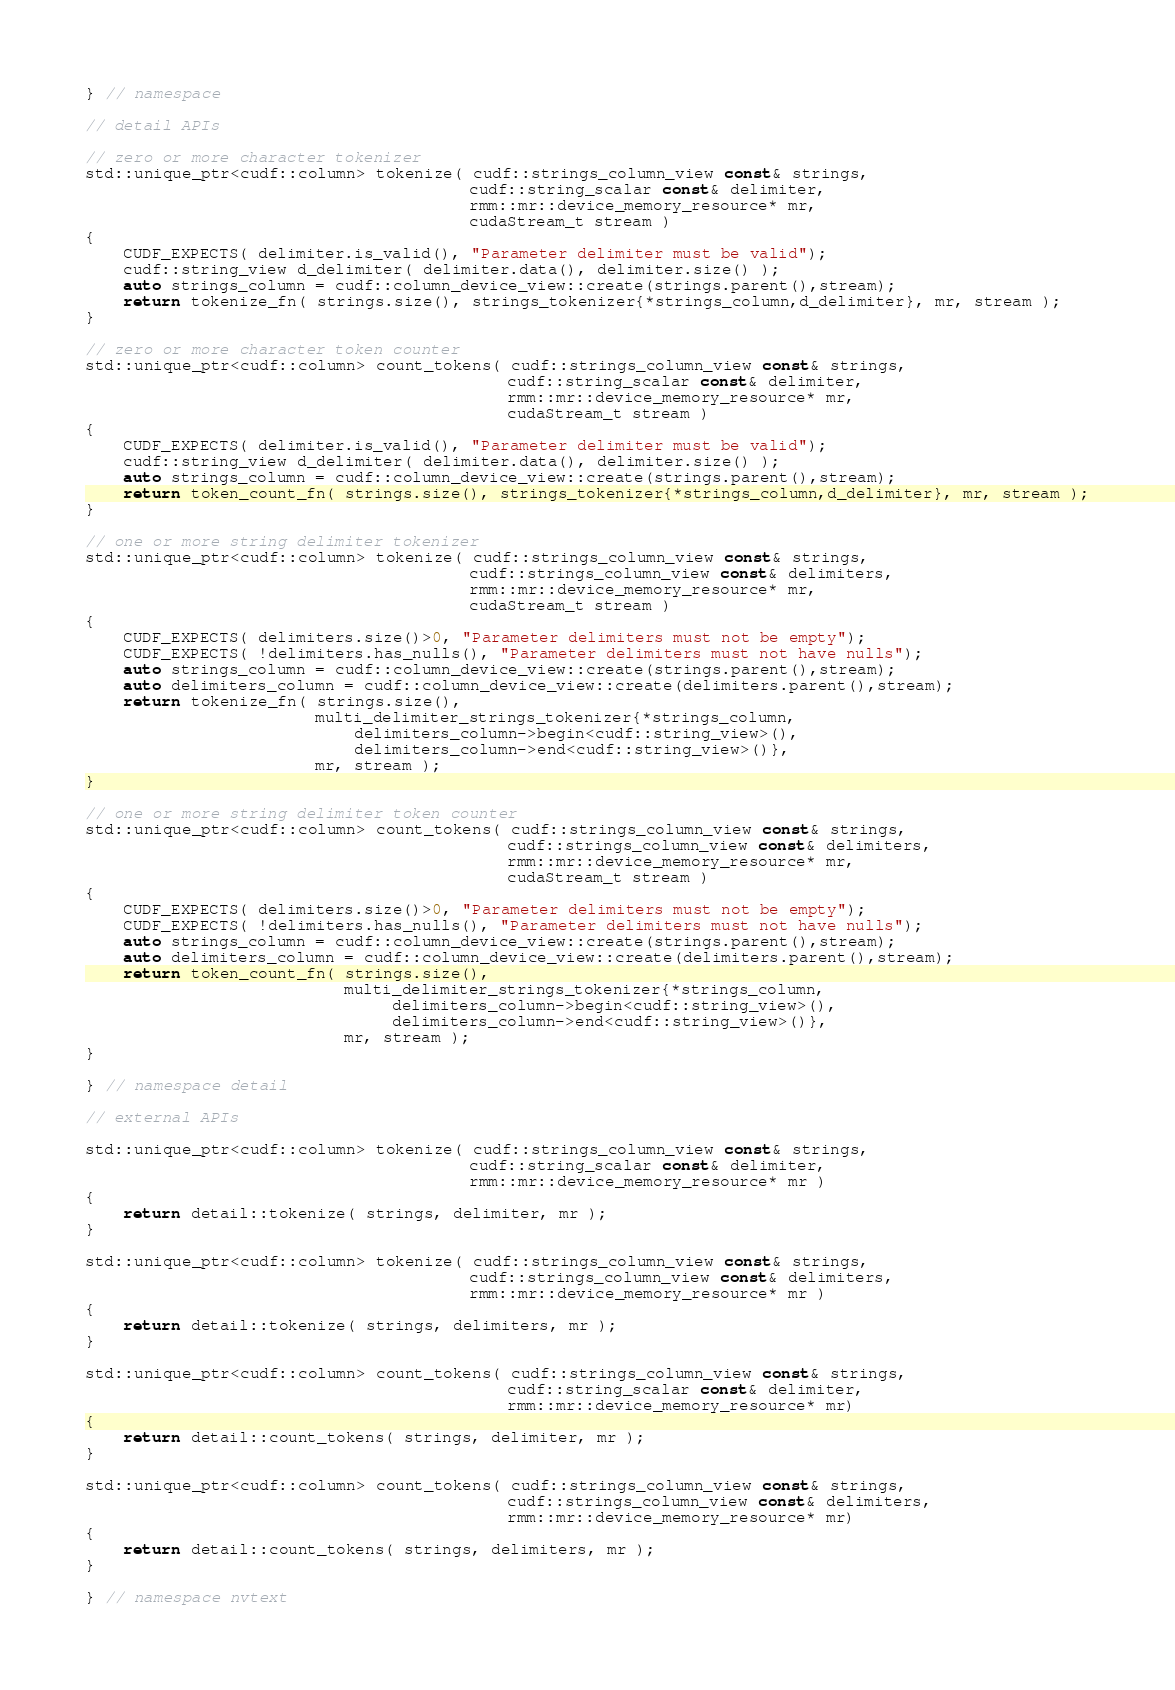<code> <loc_0><loc_0><loc_500><loc_500><_Cuda_>
} // namespace

// detail APIs

// zero or more character tokenizer
std::unique_ptr<cudf::column> tokenize( cudf::strings_column_view const& strings,
                                        cudf::string_scalar const& delimiter,
                                        rmm::mr::device_memory_resource* mr,
                                        cudaStream_t stream )
{
    CUDF_EXPECTS( delimiter.is_valid(), "Parameter delimiter must be valid");
    cudf::string_view d_delimiter( delimiter.data(), delimiter.size() );
    auto strings_column = cudf::column_device_view::create(strings.parent(),stream);
    return tokenize_fn( strings.size(), strings_tokenizer{*strings_column,d_delimiter}, mr, stream );
}

// zero or more character token counter
std::unique_ptr<cudf::column> count_tokens( cudf::strings_column_view const& strings,
                                            cudf::string_scalar const& delimiter,
                                            rmm::mr::device_memory_resource* mr,
                                            cudaStream_t stream )
{
    CUDF_EXPECTS( delimiter.is_valid(), "Parameter delimiter must be valid");
    cudf::string_view d_delimiter( delimiter.data(), delimiter.size() );
    auto strings_column = cudf::column_device_view::create(strings.parent(),stream);
    return token_count_fn( strings.size(), strings_tokenizer{*strings_column,d_delimiter}, mr, stream );
}

// one or more string delimiter tokenizer
std::unique_ptr<cudf::column> tokenize( cudf::strings_column_view const& strings,
                                        cudf::strings_column_view const& delimiters,
                                        rmm::mr::device_memory_resource* mr,
                                        cudaStream_t stream )
{
    CUDF_EXPECTS( delimiters.size()>0, "Parameter delimiters must not be empty");
    CUDF_EXPECTS( !delimiters.has_nulls(), "Parameter delimiters must not have nulls");
    auto strings_column = cudf::column_device_view::create(strings.parent(),stream);
    auto delimiters_column = cudf::column_device_view::create(delimiters.parent(),stream);
    return tokenize_fn( strings.size(),
                        multi_delimiter_strings_tokenizer{*strings_column,
                            delimiters_column->begin<cudf::string_view>(),
                            delimiters_column->end<cudf::string_view>()},
                        mr, stream );
}

// one or more string delimiter token counter
std::unique_ptr<cudf::column> count_tokens( cudf::strings_column_view const& strings,
                                            cudf::strings_column_view const& delimiters,
                                            rmm::mr::device_memory_resource* mr,
                                            cudaStream_t stream )
{
    CUDF_EXPECTS( delimiters.size()>0, "Parameter delimiters must not be empty");
    CUDF_EXPECTS( !delimiters.has_nulls(), "Parameter delimiters must not have nulls");
    auto strings_column = cudf::column_device_view::create(strings.parent(),stream);
    auto delimiters_column = cudf::column_device_view::create(delimiters.parent(),stream);
    return token_count_fn( strings.size(),
                           multi_delimiter_strings_tokenizer{*strings_column,
                                delimiters_column->begin<cudf::string_view>(),
                                delimiters_column->end<cudf::string_view>()},
                           mr, stream );
}

} // namespace detail

// external APIs

std::unique_ptr<cudf::column> tokenize( cudf::strings_column_view const& strings,
                                        cudf::string_scalar const& delimiter,
                                        rmm::mr::device_memory_resource* mr )
{
    return detail::tokenize( strings, delimiter, mr );
}

std::unique_ptr<cudf::column> tokenize( cudf::strings_column_view const& strings,
                                        cudf::strings_column_view const& delimiters,
                                        rmm::mr::device_memory_resource* mr )
{
    return detail::tokenize( strings, delimiters, mr );
}

std::unique_ptr<cudf::column> count_tokens( cudf::strings_column_view const& strings,
                                            cudf::string_scalar const& delimiter,
                                            rmm::mr::device_memory_resource* mr)
{
    return detail::count_tokens( strings, delimiter, mr );
}

std::unique_ptr<cudf::column> count_tokens( cudf::strings_column_view const& strings,
                                            cudf::strings_column_view const& delimiters,
                                            rmm::mr::device_memory_resource* mr)
{
    return detail::count_tokens( strings, delimiters, mr );
}

} // namespace nvtext
</code> 